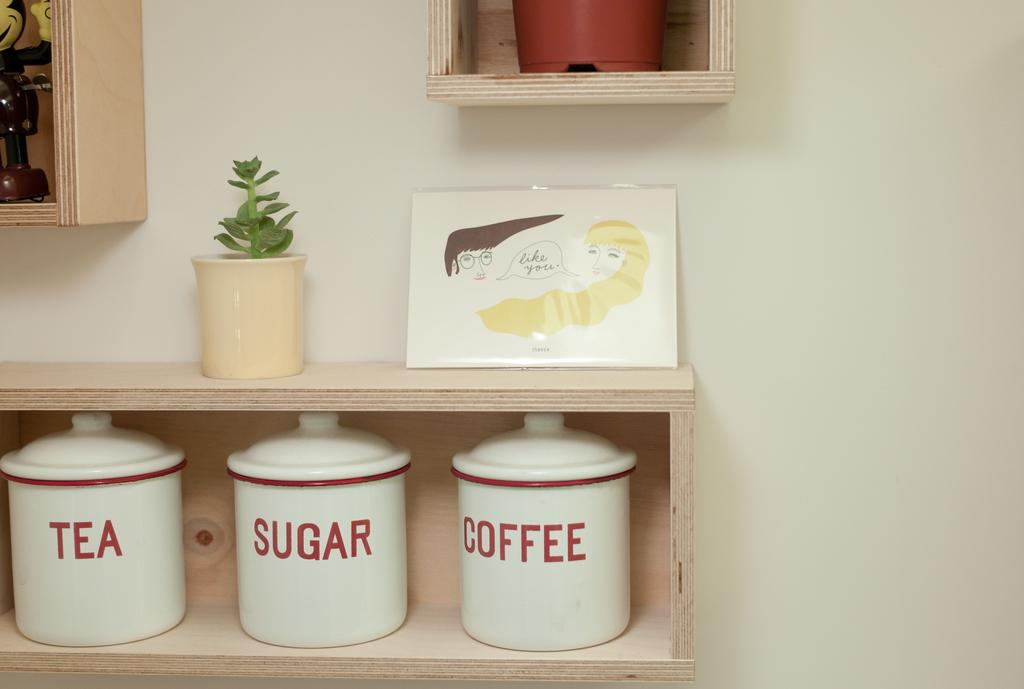<image>
Present a compact description of the photo's key features. The middle container contains a lot of sugar 